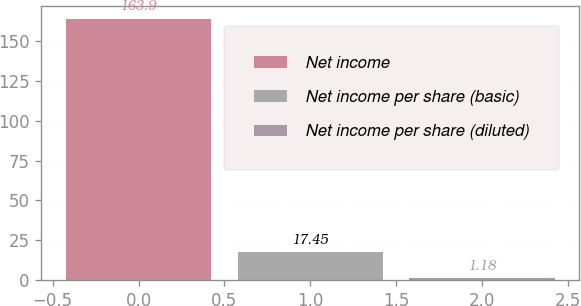Convert chart. <chart><loc_0><loc_0><loc_500><loc_500><bar_chart><fcel>Net income<fcel>Net income per share (basic)<fcel>Net income per share (diluted)<nl><fcel>163.9<fcel>17.45<fcel>1.18<nl></chart> 